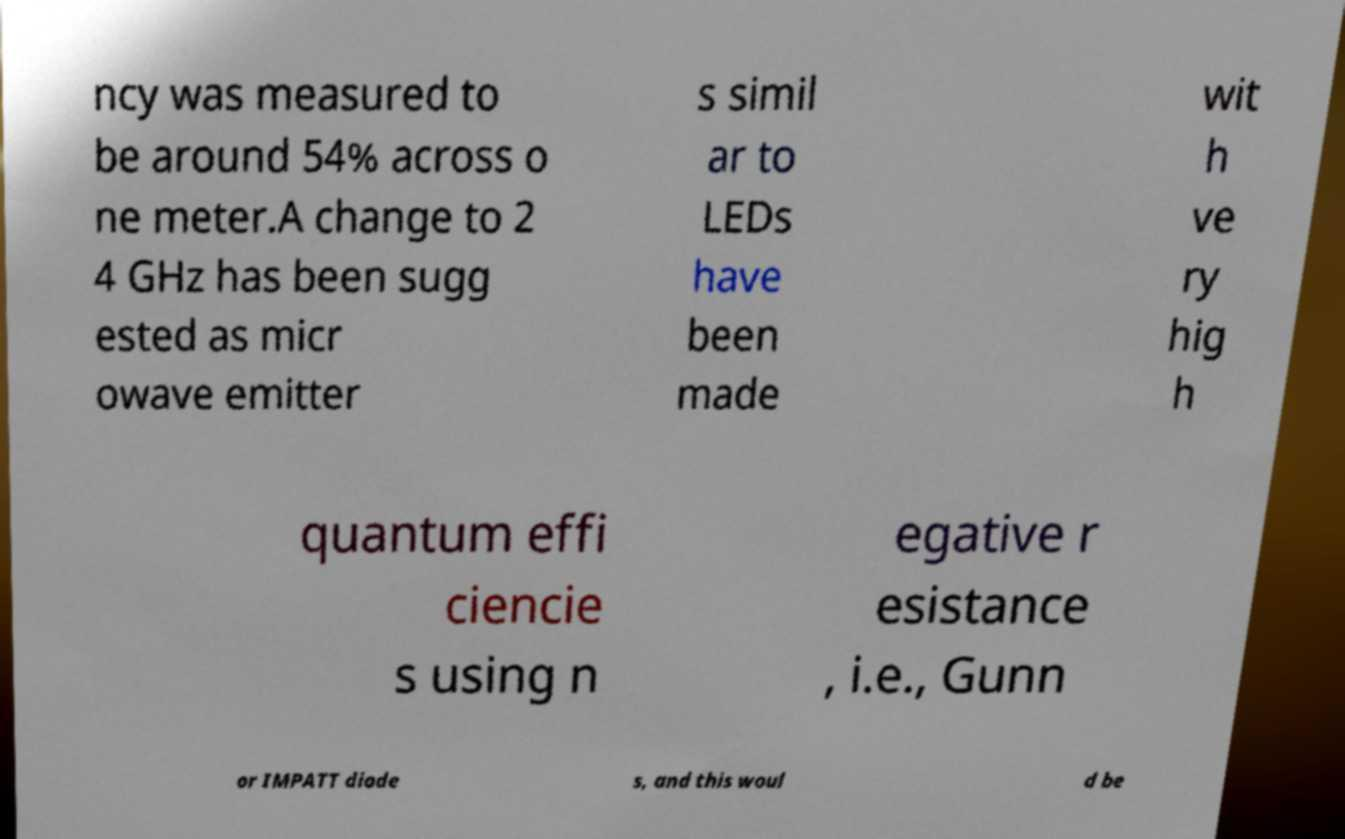Please identify and transcribe the text found in this image. ncy was measured to be around 54% across o ne meter.A change to 2 4 GHz has been sugg ested as micr owave emitter s simil ar to LEDs have been made wit h ve ry hig h quantum effi ciencie s using n egative r esistance , i.e., Gunn or IMPATT diode s, and this woul d be 